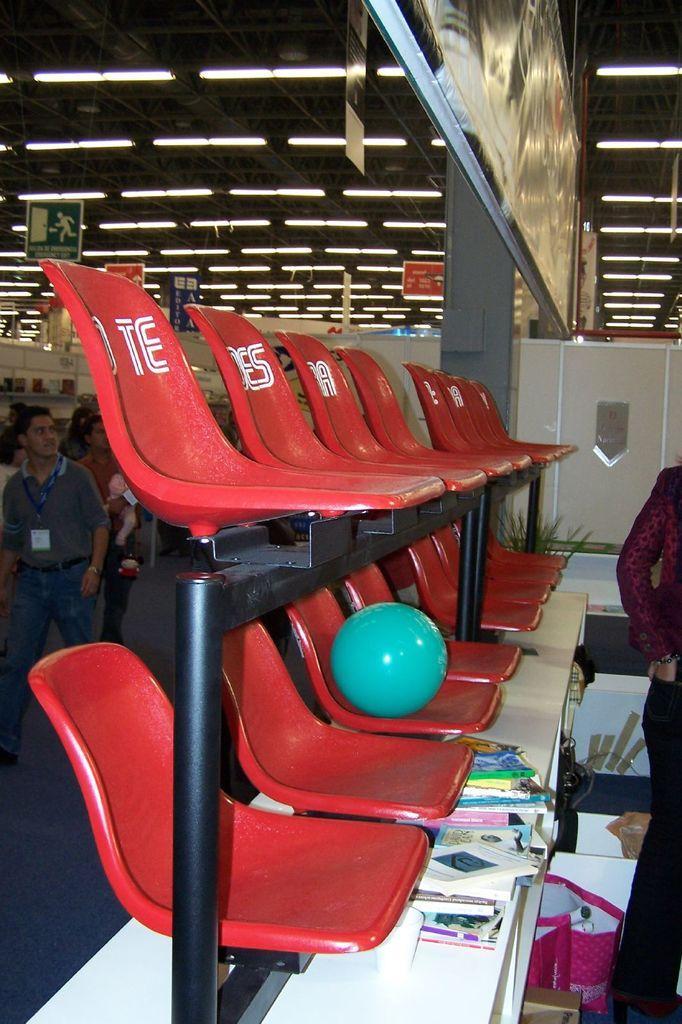In one or two sentences, can you explain what this image depicts? There are red color chairs. On the top the chairs there are another chairs. There is a green color ball on the chair. And on the table there are some books. We can see a lady to the right corner. And a man to the left corner he is walking. On the top of the roof there are light bulbs. 